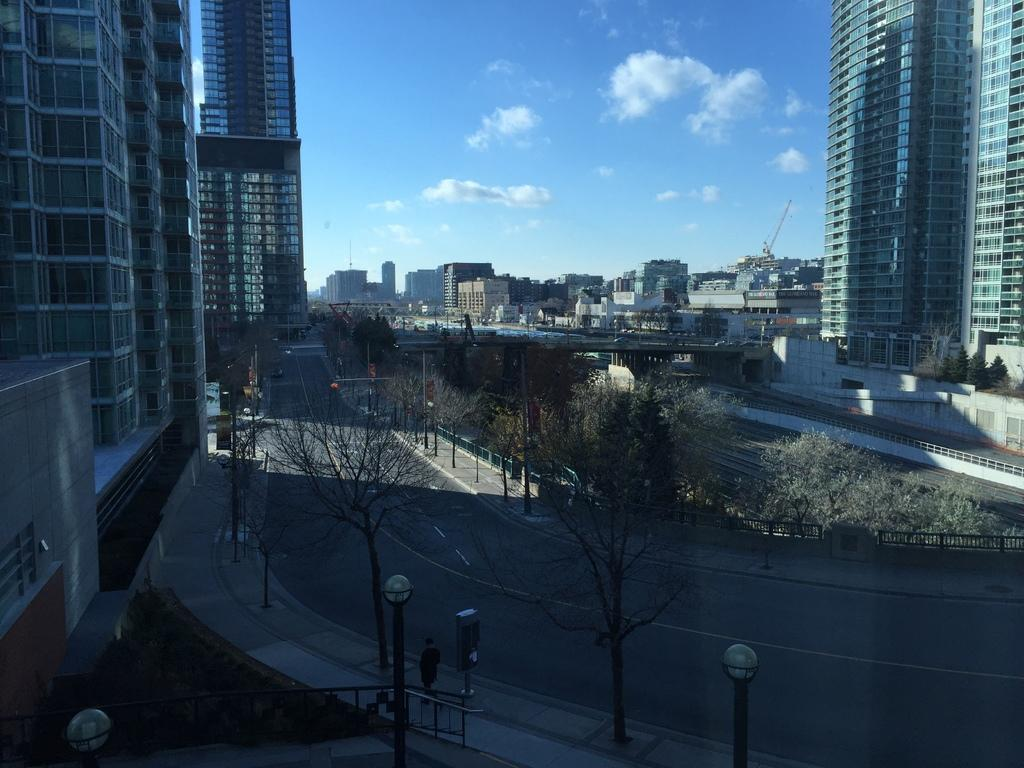What type of structures can be seen in the image? There are buildings in the image. What connects the two sides of the image? There is a bridge in the image. What type of vegetation is present? There are trees and plants in the image. What might be used for safety or support? There are railings in the image. What provides illumination in the image? There are lights in the image. What type of transportation is visible? There are vehicles in the image. What other objects can be seen? There are a few objects in the image. Who is present in the image? There is a person on a walkway in the image. What can be seen in the background of the image? The sky is visible in the background of the image. What type of rose is being held by the person in the image? There is no rose present in the image; the person is on a walkway. What does the person's stomach look like in the image? There is no information about the person's stomach in the image. What letters are being written by the person in the image? There is no indication that the person is writing any letters in the image. 